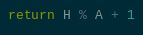Convert code to text. <code><loc_0><loc_0><loc_500><loc_500><_Python_>return H % A + 1</code> 